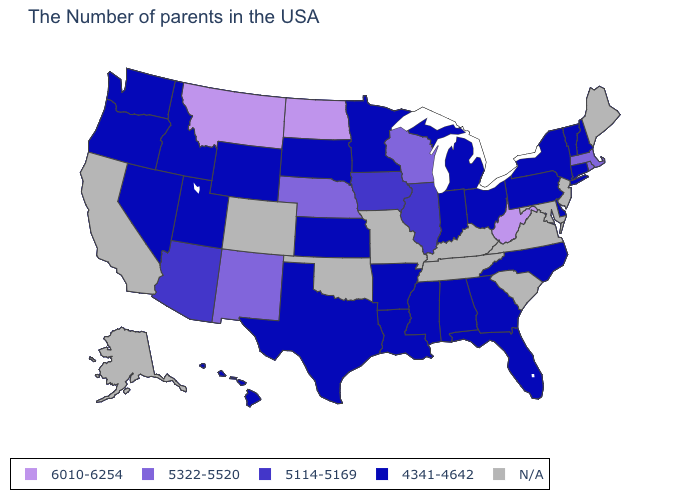Does West Virginia have the highest value in the USA?
Concise answer only. Yes. Which states hav the highest value in the MidWest?
Keep it brief. North Dakota. What is the highest value in the USA?
Write a very short answer. 6010-6254. Does the map have missing data?
Answer briefly. Yes. What is the value of Vermont?
Quick response, please. 4341-4642. What is the value of Virginia?
Keep it brief. N/A. What is the value of North Carolina?
Quick response, please. 4341-4642. Does North Dakota have the highest value in the USA?
Concise answer only. Yes. What is the value of North Carolina?
Write a very short answer. 4341-4642. How many symbols are there in the legend?
Keep it brief. 5. Name the states that have a value in the range 5114-5169?
Answer briefly. Illinois, Iowa, Arizona. Name the states that have a value in the range 4341-4642?
Give a very brief answer. New Hampshire, Vermont, Connecticut, New York, Delaware, Pennsylvania, North Carolina, Ohio, Florida, Georgia, Michigan, Indiana, Alabama, Mississippi, Louisiana, Arkansas, Minnesota, Kansas, Texas, South Dakota, Wyoming, Utah, Idaho, Nevada, Washington, Oregon, Hawaii. What is the value of Florida?
Quick response, please. 4341-4642. 